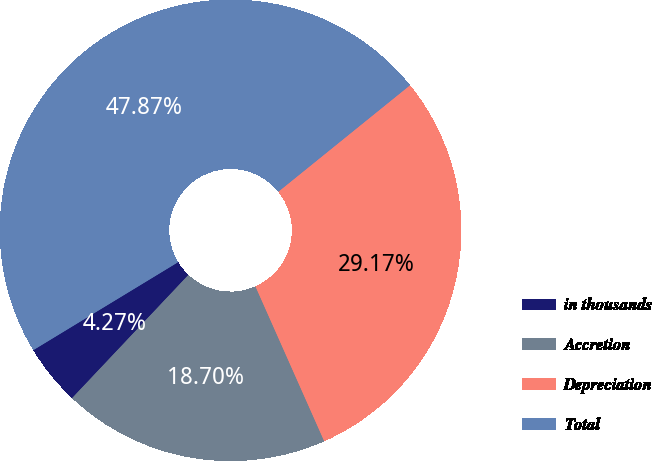<chart> <loc_0><loc_0><loc_500><loc_500><pie_chart><fcel>in thousands<fcel>Accretion<fcel>Depreciation<fcel>Total<nl><fcel>4.27%<fcel>18.7%<fcel>29.17%<fcel>47.87%<nl></chart> 